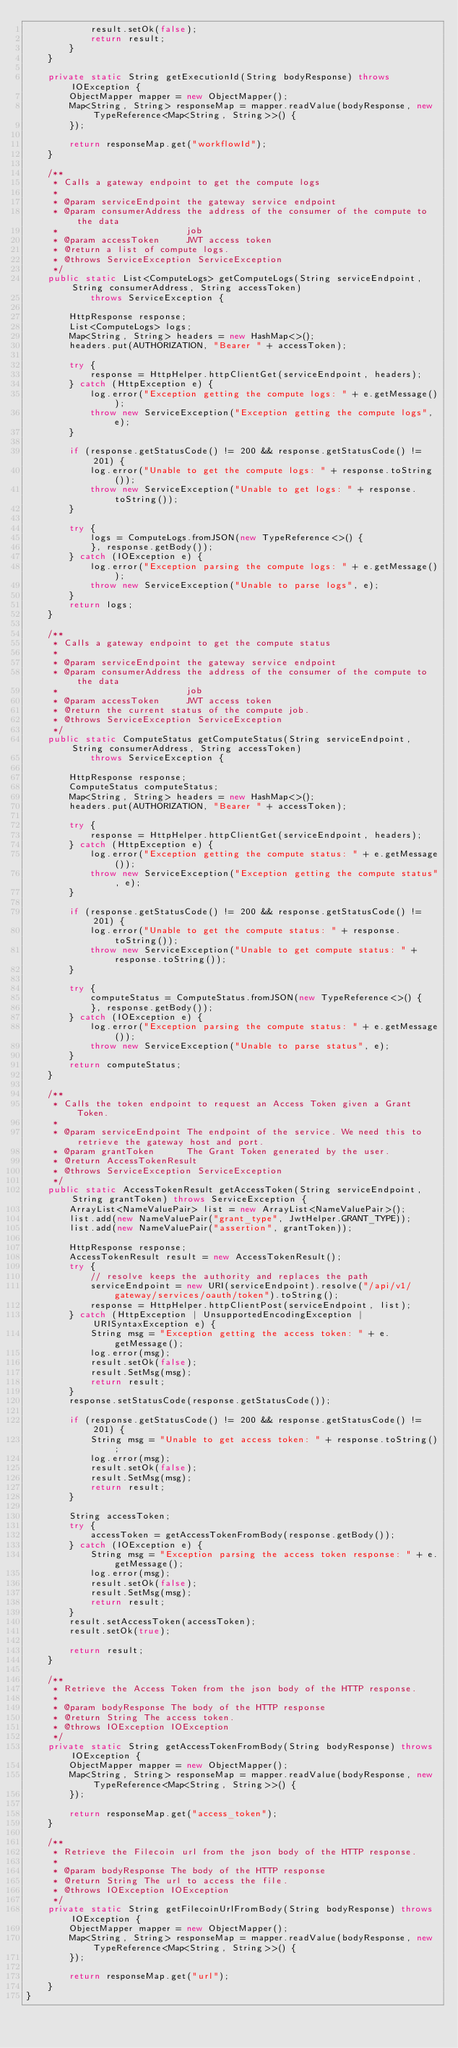Convert code to text. <code><loc_0><loc_0><loc_500><loc_500><_Java_>            result.setOk(false);
            return result;
        }
    }

    private static String getExecutionId(String bodyResponse) throws IOException {
        ObjectMapper mapper = new ObjectMapper();
        Map<String, String> responseMap = mapper.readValue(bodyResponse, new TypeReference<Map<String, String>>() {
        });

        return responseMap.get("workflowId");
    }

    /**
     * Calls a gateway endpoint to get the compute logs
     *
     * @param serviceEndpoint the gateway service endpoint
     * @param consumerAddress the address of the consumer of the compute to the data
     *                        job
     * @param accessToken     JWT access token
     * @return a list of compute logs.
     * @throws ServiceException ServiceException
     */
    public static List<ComputeLogs> getComputeLogs(String serviceEndpoint, String consumerAddress, String accessToken)
            throws ServiceException {

        HttpResponse response;
        List<ComputeLogs> logs;
        Map<String, String> headers = new HashMap<>();
        headers.put(AUTHORIZATION, "Bearer " + accessToken);

        try {
            response = HttpHelper.httpClientGet(serviceEndpoint, headers);
        } catch (HttpException e) {
            log.error("Exception getting the compute logs: " + e.getMessage());
            throw new ServiceException("Exception getting the compute logs", e);
        }

        if (response.getStatusCode() != 200 && response.getStatusCode() != 201) {
            log.error("Unable to get the compute logs: " + response.toString());
            throw new ServiceException("Unable to get logs: " + response.toString());
        }

        try {
            logs = ComputeLogs.fromJSON(new TypeReference<>() {
            }, response.getBody());
        } catch (IOException e) {
            log.error("Exception parsing the compute logs: " + e.getMessage());
            throw new ServiceException("Unable to parse logs", e);
        }
        return logs;
    }

    /**
     * Calls a gateway endpoint to get the compute status
     *
     * @param serviceEndpoint the gateway service endpoint
     * @param consumerAddress the address of the consumer of the compute to the data
     *                        job
     * @param accessToken     JWT access token
     * @return the current status of the compute job.
     * @throws ServiceException ServiceException
     */
    public static ComputeStatus getComputeStatus(String serviceEndpoint, String consumerAddress, String accessToken)
            throws ServiceException {

        HttpResponse response;
        ComputeStatus computeStatus;
        Map<String, String> headers = new HashMap<>();
        headers.put(AUTHORIZATION, "Bearer " + accessToken);

        try {
            response = HttpHelper.httpClientGet(serviceEndpoint, headers);
        } catch (HttpException e) {
            log.error("Exception getting the compute status: " + e.getMessage());
            throw new ServiceException("Exception getting the compute status", e);
        }

        if (response.getStatusCode() != 200 && response.getStatusCode() != 201) {
            log.error("Unable to get the compute status: " + response.toString());
            throw new ServiceException("Unable to get compute status: " + response.toString());
        }

        try {
            computeStatus = ComputeStatus.fromJSON(new TypeReference<>() {
            }, response.getBody());
        } catch (IOException e) {
            log.error("Exception parsing the compute status: " + e.getMessage());
            throw new ServiceException("Unable to parse status", e);
        }
        return computeStatus;
    }

    /**
     * Calls the token endpoint to request an Access Token given a Grant Token.
     *
     * @param serviceEndpoint The endpoint of the service. We need this to retrieve the gateway host and port.
     * @param grantToken      The Grant Token generated by the user.
     * @return AccessTokenResult
     * @throws ServiceException ServiceException
     */
    public static AccessTokenResult getAccessToken(String serviceEndpoint, String grantToken) throws ServiceException {
        ArrayList<NameValuePair> list = new ArrayList<NameValuePair>();
        list.add(new NameValuePair("grant_type", JwtHelper.GRANT_TYPE));
        list.add(new NameValuePair("assertion", grantToken));

        HttpResponse response;
        AccessTokenResult result = new AccessTokenResult();
        try {
            // resolve keeps the authority and replaces the path
            serviceEndpoint = new URI(serviceEndpoint).resolve("/api/v1/gateway/services/oauth/token").toString();
            response = HttpHelper.httpClientPost(serviceEndpoint, list);
        } catch (HttpException | UnsupportedEncodingException | URISyntaxException e) {
            String msg = "Exception getting the access token: " + e.getMessage();
            log.error(msg);
            result.setOk(false);
            result.SetMsg(msg);
            return result;
        }
        response.setStatusCode(response.getStatusCode());

        if (response.getStatusCode() != 200 && response.getStatusCode() != 201) {
            String msg = "Unable to get access token: " + response.toString();
            log.error(msg);
            result.setOk(false);
            result.SetMsg(msg);
            return result;
        }

        String accessToken;
        try {
            accessToken = getAccessTokenFromBody(response.getBody());
        } catch (IOException e) {
            String msg = "Exception parsing the access token response: " + e.getMessage();
            log.error(msg);
            result.setOk(false);
            result.SetMsg(msg);
            return result;
        }
        result.setAccessToken(accessToken);
        result.setOk(true);

        return result;
    }

    /**
     * Retrieve the Access Token from the json body of the HTTP response.
     *
     * @param bodyResponse The body of the HTTP response
     * @return String The access token.
     * @throws IOException IOException
     */
    private static String getAccessTokenFromBody(String bodyResponse) throws IOException {
        ObjectMapper mapper = new ObjectMapper();
        Map<String, String> responseMap = mapper.readValue(bodyResponse, new TypeReference<Map<String, String>>() {
        });

        return responseMap.get("access_token");
    }

    /**
     * Retrieve the Filecoin url from the json body of the HTTP response.
     *
     * @param bodyResponse The body of the HTTP response
     * @return String The url to access the file.
     * @throws IOException IOException
     */
    private static String getFilecoinUrlFromBody(String bodyResponse) throws IOException {
        ObjectMapper mapper = new ObjectMapper();
        Map<String, String> responseMap = mapper.readValue(bodyResponse, new TypeReference<Map<String, String>>() {
        });

        return responseMap.get("url");
    }
}
</code> 